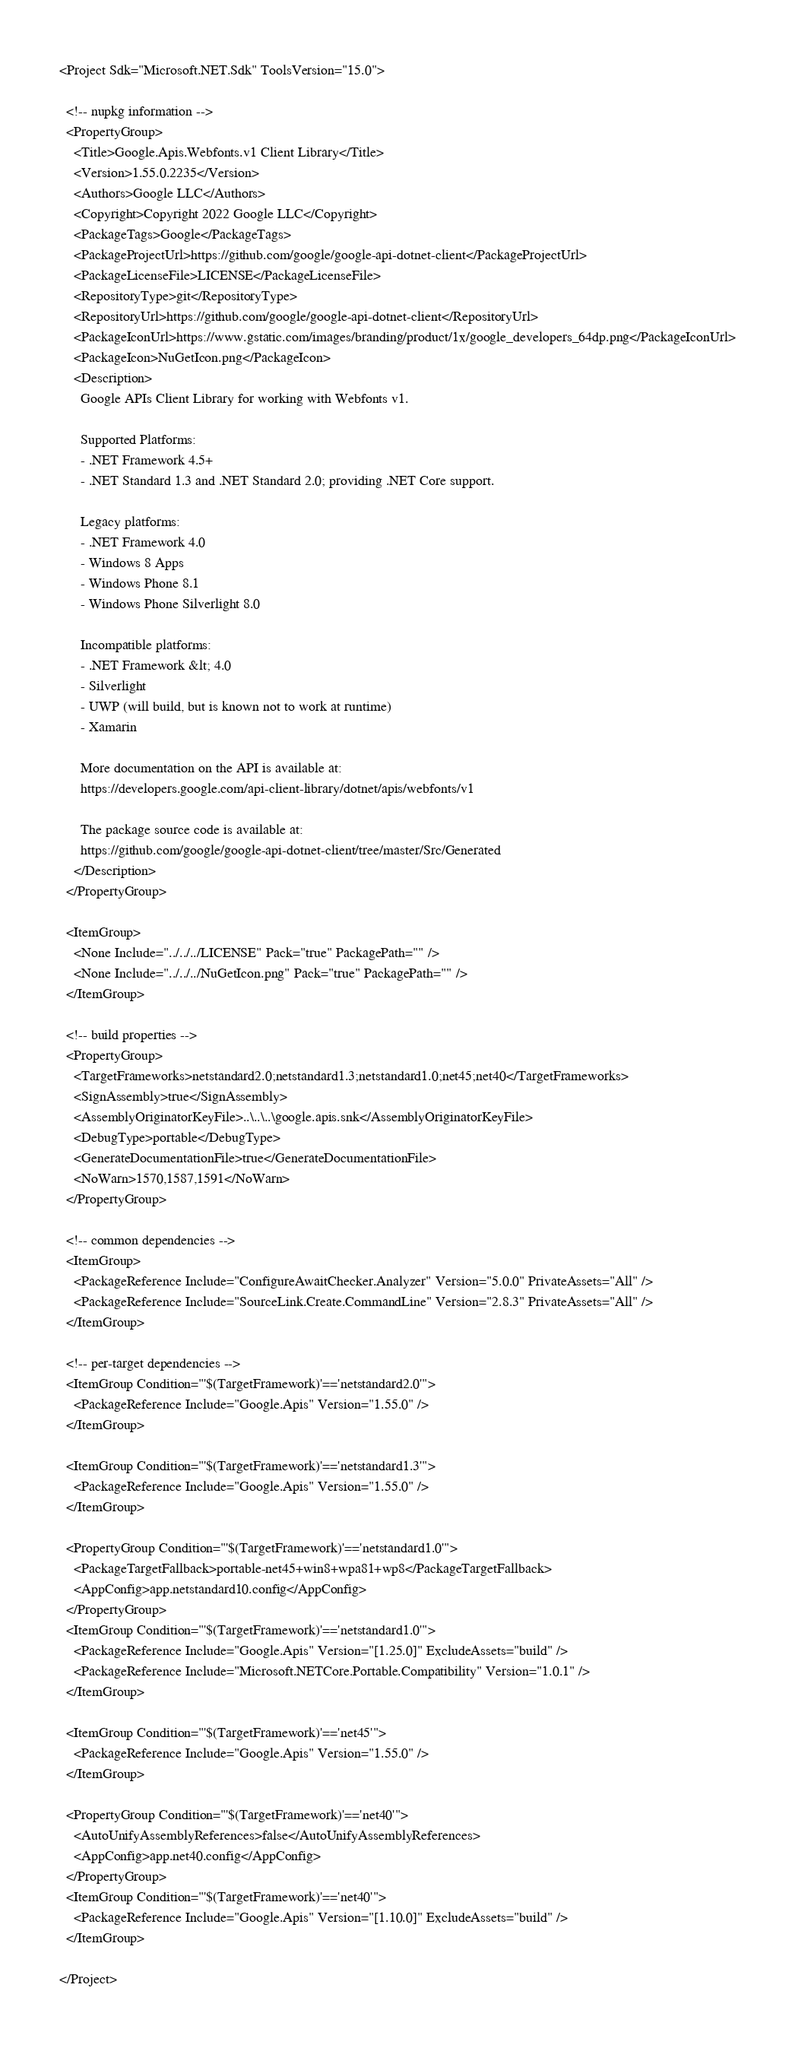<code> <loc_0><loc_0><loc_500><loc_500><_XML_><Project Sdk="Microsoft.NET.Sdk" ToolsVersion="15.0">

  <!-- nupkg information -->
  <PropertyGroup>
    <Title>Google.Apis.Webfonts.v1 Client Library</Title>
    <Version>1.55.0.2235</Version>
    <Authors>Google LLC</Authors>
    <Copyright>Copyright 2022 Google LLC</Copyright>
    <PackageTags>Google</PackageTags>
    <PackageProjectUrl>https://github.com/google/google-api-dotnet-client</PackageProjectUrl>
    <PackageLicenseFile>LICENSE</PackageLicenseFile>
    <RepositoryType>git</RepositoryType>
    <RepositoryUrl>https://github.com/google/google-api-dotnet-client</RepositoryUrl>
    <PackageIconUrl>https://www.gstatic.com/images/branding/product/1x/google_developers_64dp.png</PackageIconUrl>
    <PackageIcon>NuGetIcon.png</PackageIcon>
    <Description>
      Google APIs Client Library for working with Webfonts v1.

      Supported Platforms:
      - .NET Framework 4.5+
      - .NET Standard 1.3 and .NET Standard 2.0; providing .NET Core support.

      Legacy platforms:
      - .NET Framework 4.0
      - Windows 8 Apps
      - Windows Phone 8.1
      - Windows Phone Silverlight 8.0

      Incompatible platforms:
      - .NET Framework &lt; 4.0
      - Silverlight
      - UWP (will build, but is known not to work at runtime)
      - Xamarin

      More documentation on the API is available at:
      https://developers.google.com/api-client-library/dotnet/apis/webfonts/v1

      The package source code is available at:
      https://github.com/google/google-api-dotnet-client/tree/master/Src/Generated
    </Description>
  </PropertyGroup>

  <ItemGroup>
    <None Include="../../../LICENSE" Pack="true" PackagePath="" />
    <None Include="../../../NuGetIcon.png" Pack="true" PackagePath="" />
  </ItemGroup>

  <!-- build properties -->
  <PropertyGroup>
    <TargetFrameworks>netstandard2.0;netstandard1.3;netstandard1.0;net45;net40</TargetFrameworks>
    <SignAssembly>true</SignAssembly>
    <AssemblyOriginatorKeyFile>..\..\..\google.apis.snk</AssemblyOriginatorKeyFile>
    <DebugType>portable</DebugType>
    <GenerateDocumentationFile>true</GenerateDocumentationFile>
    <NoWarn>1570,1587,1591</NoWarn>
  </PropertyGroup>

  <!-- common dependencies -->
  <ItemGroup>
    <PackageReference Include="ConfigureAwaitChecker.Analyzer" Version="5.0.0" PrivateAssets="All" />
    <PackageReference Include="SourceLink.Create.CommandLine" Version="2.8.3" PrivateAssets="All" />
  </ItemGroup>

  <!-- per-target dependencies -->
  <ItemGroup Condition="'$(TargetFramework)'=='netstandard2.0'">
    <PackageReference Include="Google.Apis" Version="1.55.0" />
  </ItemGroup>

  <ItemGroup Condition="'$(TargetFramework)'=='netstandard1.3'">
    <PackageReference Include="Google.Apis" Version="1.55.0" />
  </ItemGroup>

  <PropertyGroup Condition="'$(TargetFramework)'=='netstandard1.0'">
    <PackageTargetFallback>portable-net45+win8+wpa81+wp8</PackageTargetFallback>
    <AppConfig>app.netstandard10.config</AppConfig>
  </PropertyGroup>
  <ItemGroup Condition="'$(TargetFramework)'=='netstandard1.0'">
    <PackageReference Include="Google.Apis" Version="[1.25.0]" ExcludeAssets="build" />
    <PackageReference Include="Microsoft.NETCore.Portable.Compatibility" Version="1.0.1" />
  </ItemGroup>

  <ItemGroup Condition="'$(TargetFramework)'=='net45'">
    <PackageReference Include="Google.Apis" Version="1.55.0" />
  </ItemGroup>

  <PropertyGroup Condition="'$(TargetFramework)'=='net40'">
    <AutoUnifyAssemblyReferences>false</AutoUnifyAssemblyReferences>
    <AppConfig>app.net40.config</AppConfig>
  </PropertyGroup>
  <ItemGroup Condition="'$(TargetFramework)'=='net40'">
    <PackageReference Include="Google.Apis" Version="[1.10.0]" ExcludeAssets="build" />
  </ItemGroup>

</Project>
</code> 